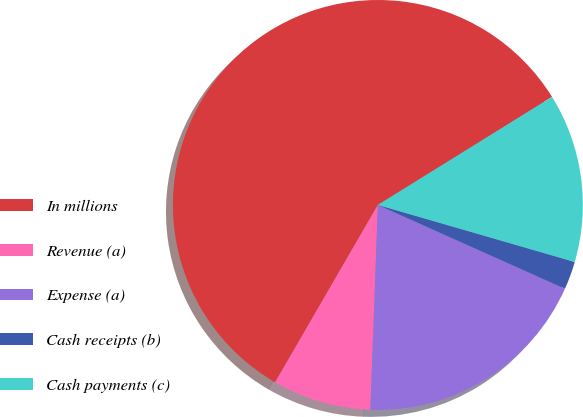Convert chart. <chart><loc_0><loc_0><loc_500><loc_500><pie_chart><fcel>In millions<fcel>Revenue (a)<fcel>Expense (a)<fcel>Cash receipts (b)<fcel>Cash payments (c)<nl><fcel>57.81%<fcel>7.77%<fcel>18.89%<fcel>2.21%<fcel>13.33%<nl></chart> 